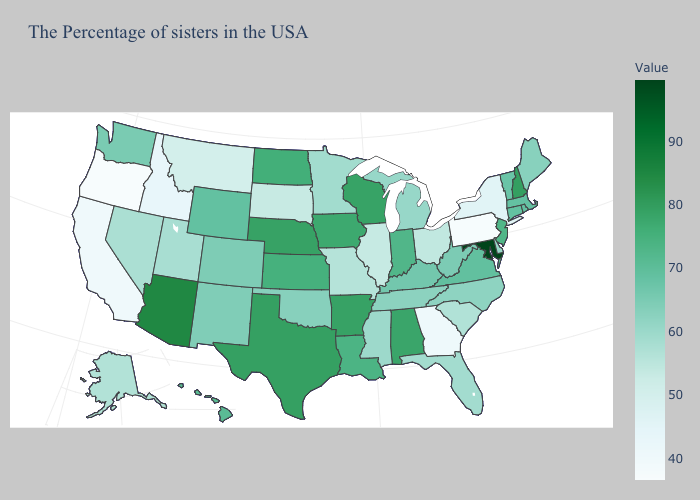Which states have the lowest value in the USA?
Give a very brief answer. Oregon. Does Utah have the highest value in the USA?
Short answer required. No. Does Maryland have the highest value in the USA?
Write a very short answer. Yes. Does the map have missing data?
Write a very short answer. No. Among the states that border North Carolina , which have the lowest value?
Concise answer only. Georgia. Does Georgia have the lowest value in the South?
Quick response, please. Yes. Among the states that border Maine , which have the lowest value?
Be succinct. New Hampshire. Among the states that border Colorado , which have the lowest value?
Concise answer only. Utah. 